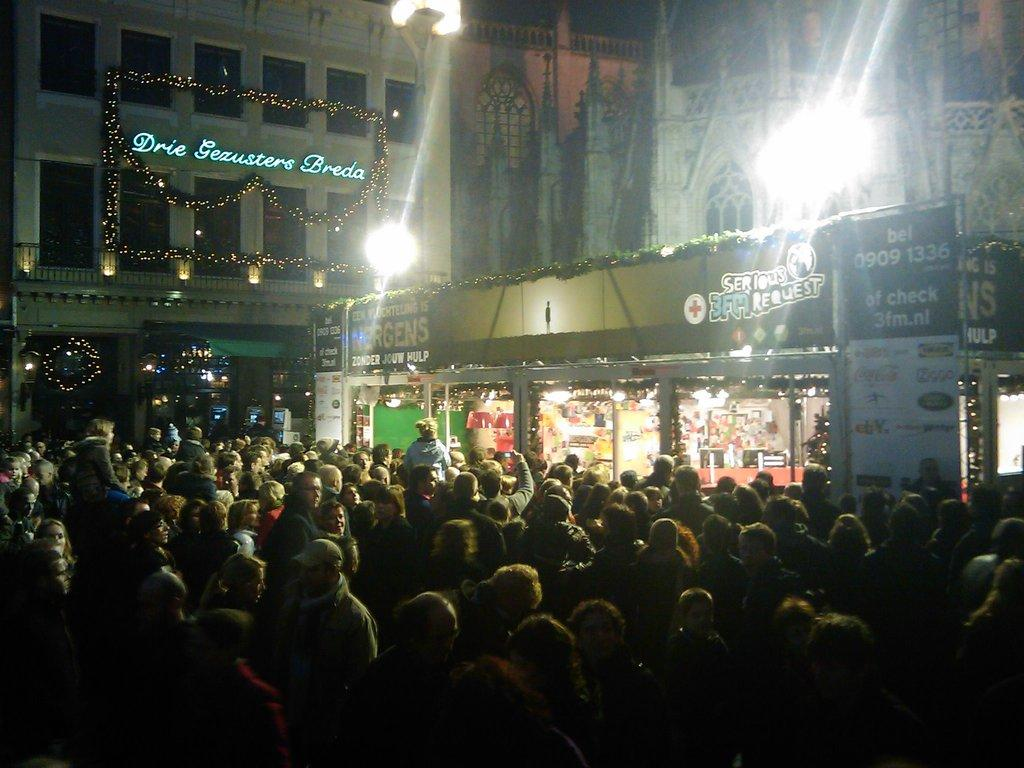How many people are in the image? There is a group of people in the image, but the exact number cannot be determined from the provided facts. What type of structures can be seen in the image? There are buildings in the image. What feature of the buildings is visible in the image? There are windows visible in the image. What can be seen illuminating the scene in the image? There are lights in the image. What type of establishments are present in the image? There are stores in the image. What objects are present in the image that are not part of the buildings or people? There are boards in the image. What type of zinc is present in the image? There is no mention of zinc in the provided facts, so it cannot be determined if any zinc is present in the image. In which direction are the people in the image facing? The provided facts do not specify the direction the people are facing, so it cannot be determined from the image. 